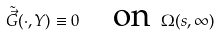<formula> <loc_0><loc_0><loc_500><loc_500>\tilde { \vec { G } } ( \cdot , Y ) \equiv 0 \quad \text {on } \, \Omega ( s , \infty )</formula> 